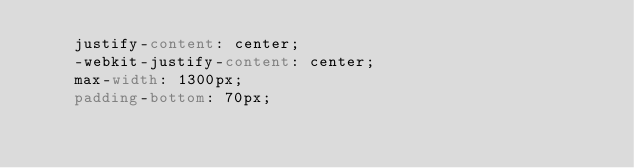<code> <loc_0><loc_0><loc_500><loc_500><_CSS_>    justify-content: center;
    -webkit-justify-content: center;
    max-width: 1300px;
    padding-bottom: 70px;</code> 